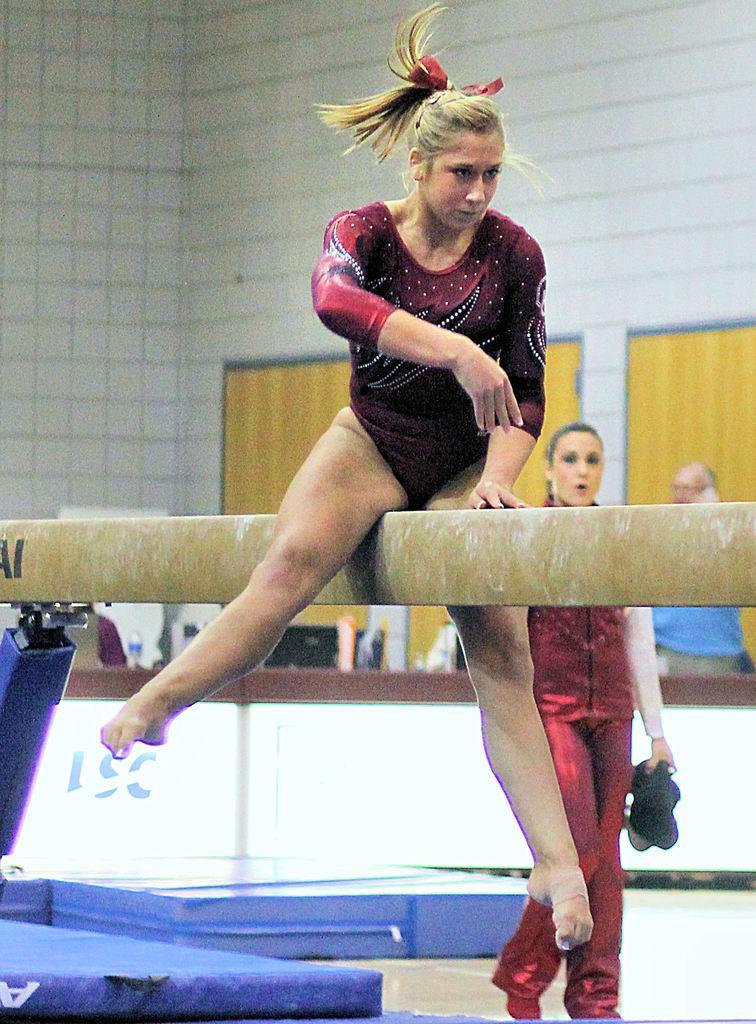Describe this image in one or two sentences. In the middle of this image, there is a woman placing a hand on a pole and balancing. Beside her, there is a blue color mattress and another woman who is in red color dress. In the background, there is a person in a blue color t-shirt and there is a white wall. 